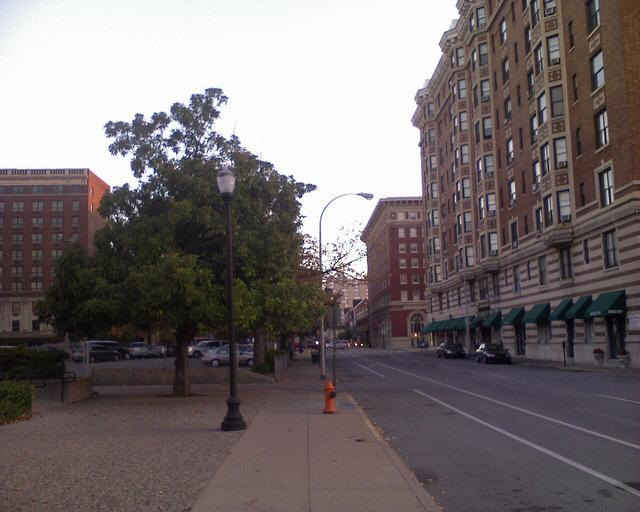During which season are the cars on this street parked?

Choices:
A) winter
B) spring
C) summer
D) fall fall 